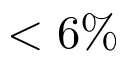<formula> <loc_0><loc_0><loc_500><loc_500>< 6 \%</formula> 